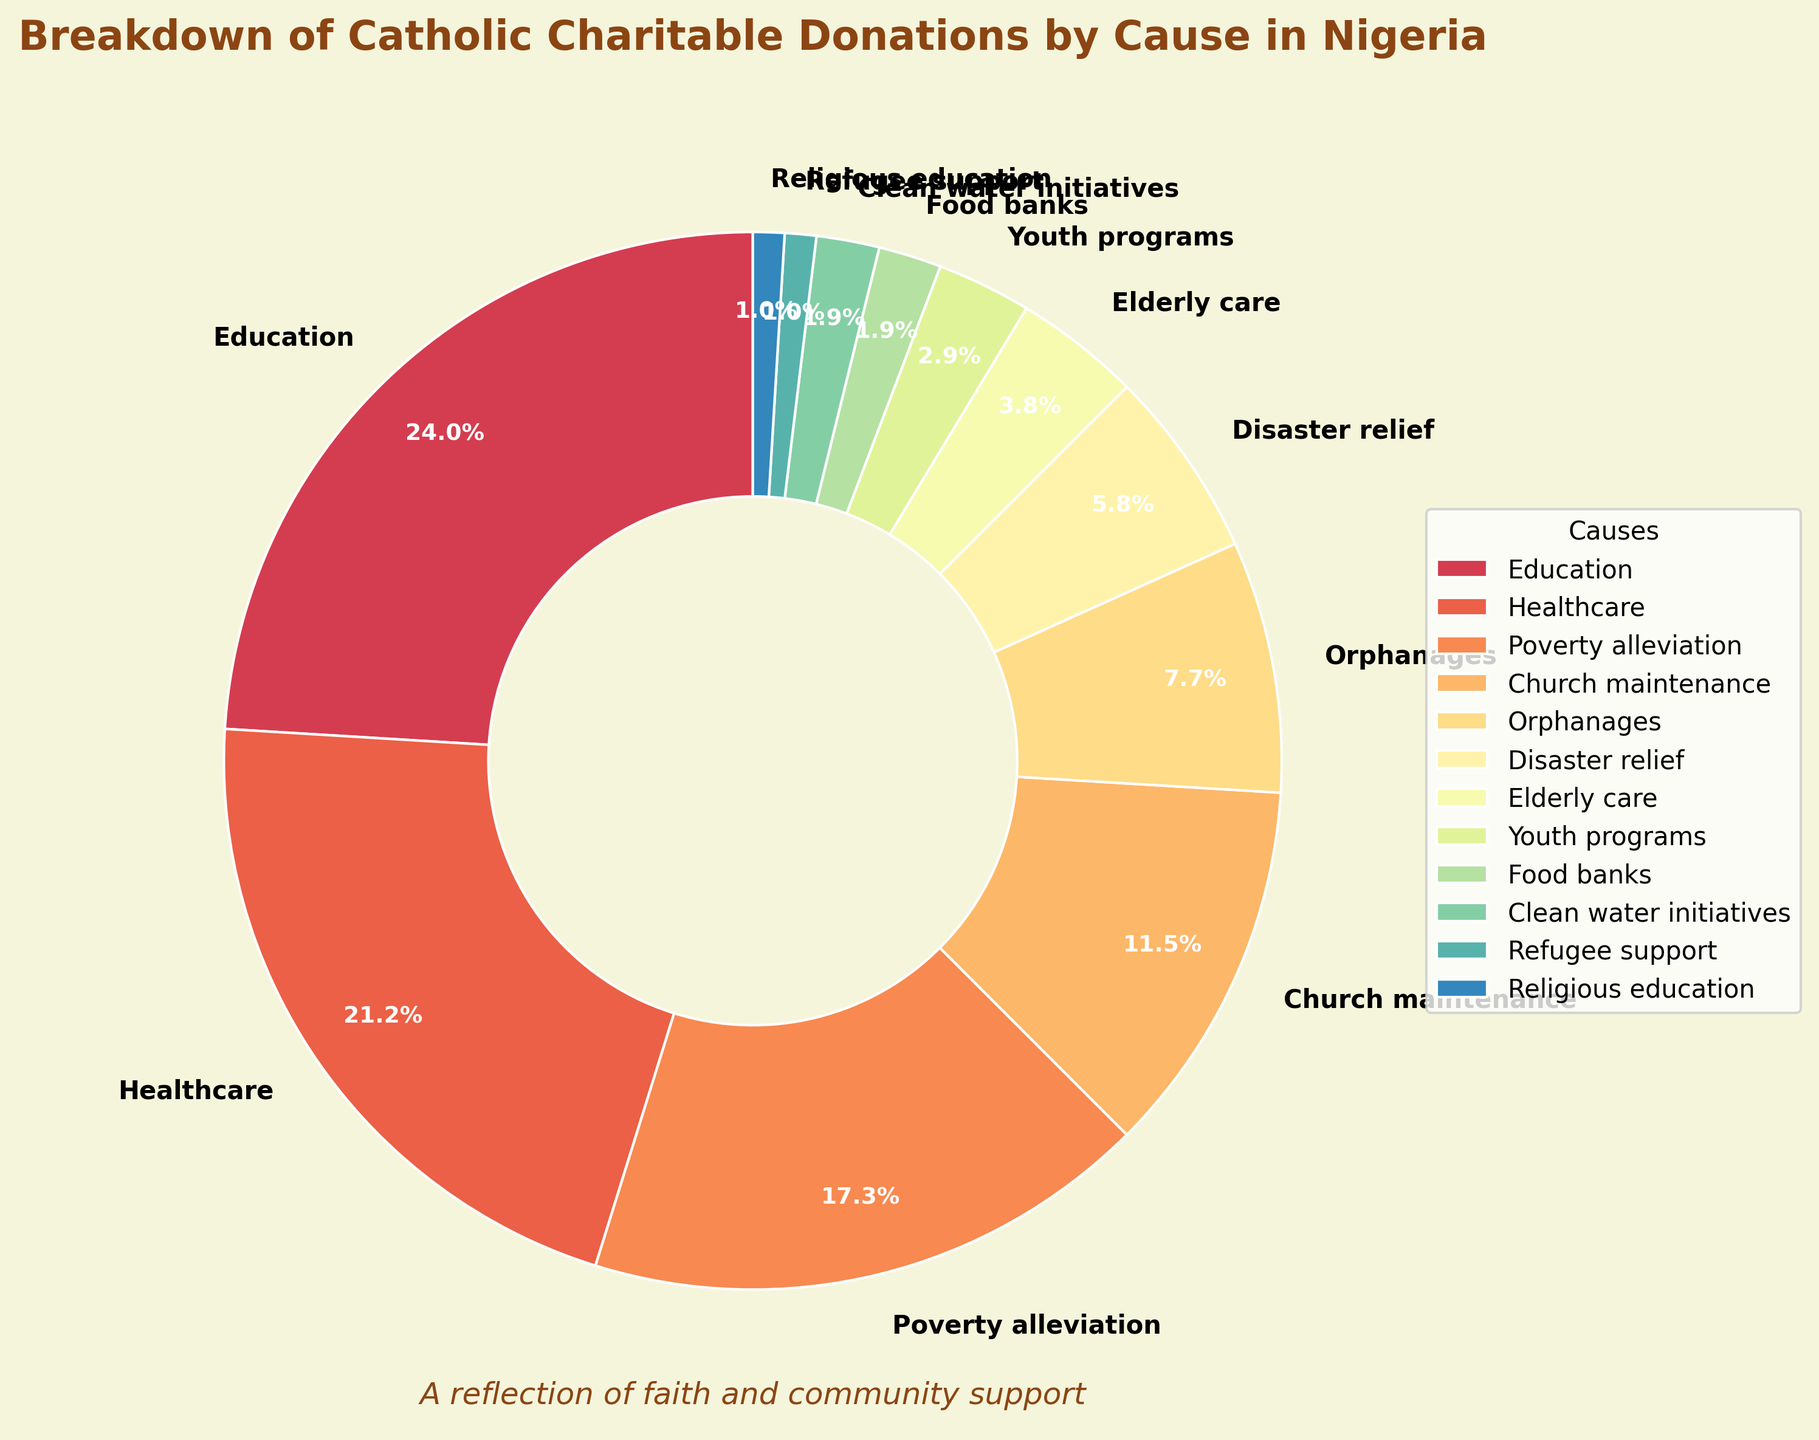Which cause receives the highest percentage of donations? By examining the pie chart, we see that the largest segment corresponds to Education. The percentage listed next to it is 25%.
Answer: Education How much more percentage does Education receive compared to Disaster relief? From the chart, Education receives 25% while Disaster relief receives 6%. Subtracting the two gives 25% - 6% = 19%.
Answer: 19% What is the total percentage of donations going to Healthcare, Church maintenance, and Orphanages combined? Individual percentages are 22% for Healthcare, 12% for Church maintenance, and 8% for Orphanages. Adding these together: 22% + 12% + 8% = 42%.
Answer: 42% Which causes receive an equal percentage of donations? By examining the chart, both Food banks and Clean water initiatives each receive 2%, and Refugee support and Religious education each receive 1%.
Answer: Food banks & Clean water initiatives, Refugee support & Religious education Compare the percentage of donations to Healthcare and Poverty alleviation. Which is higher and by how much? From the chart, Healthcare receives 22% and Poverty alleviation receives 18%. The difference is 22% - 18% = 4%. Hence, Healthcare receives 4% more.
Answer: Healthcare by 4% What is the median percentage of the donations distributed among all the causes? Arrange the percentages in ascending order: 1, 1, 2, 2, 3, 4, 6, 8, 12, 18, 22, 25. The median value (middle value) of this ordered list is between the 6th and 7th data points: (4 + 6) / 2 = 5%.
Answer: 5% What percentage of the donations goes to both Youth programs and Elderly care? According to the chart, Youth programs receive 3% and Elderly care receives 4%. Adding these together: 3% + 4% = 7%.
Answer: 7% How does the percentage of donations to Food banks compare to Clean water initiatives? By looking at the pie chart, both Food banks and Clean water initiatives each receive the same percentage of 2%.
Answer: Equal Identify the smallest segment in the pie chart and provide its percentage. The smallest segments in the pie chart are Refugee support and Religious education, each at 1%.
Answer: 1% What is the difference between the total percentage of donations for Education, Healthcare, and Poverty alleviation compared to the rest of the causes combined? The combined percentage for Education, Healthcare, and Poverty alleviation is 25% + 22% + 18% = 65%. The total percentage of all causes is 100%, so the rest of the causes combined is 100% - 65% = 35%.
Answer: 35% 